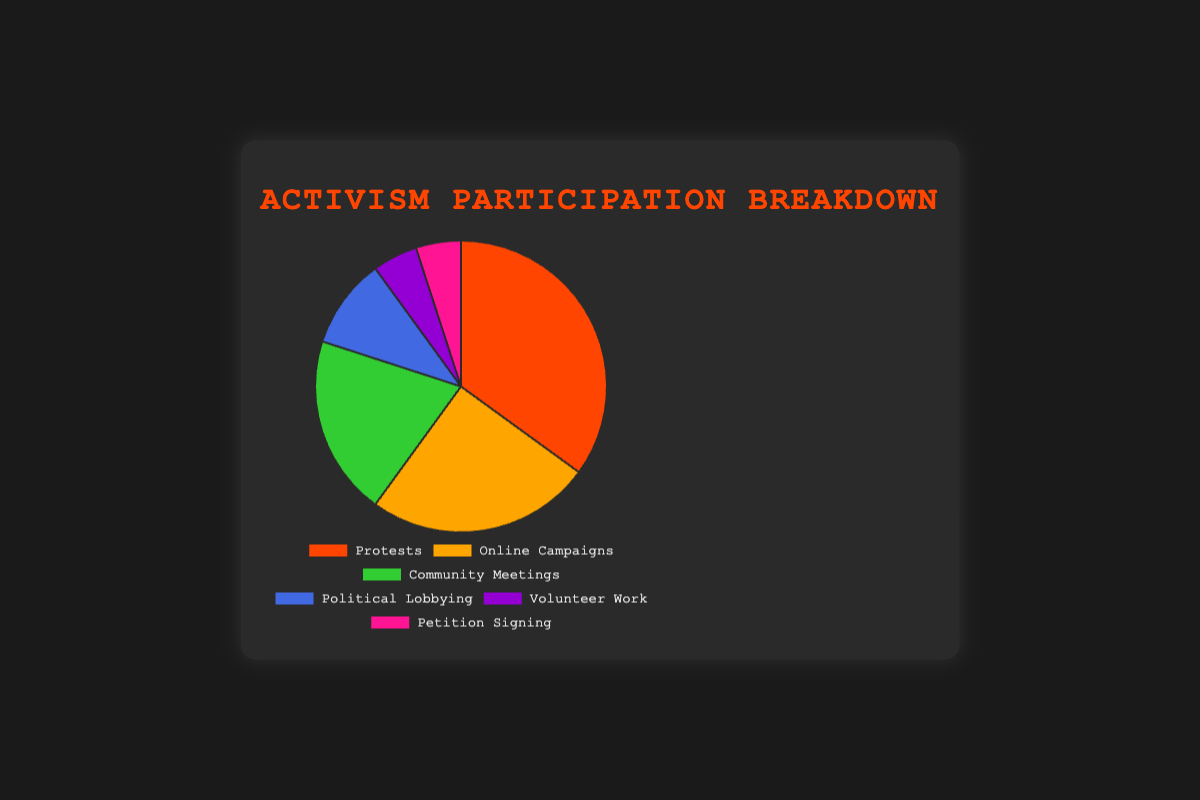Which form of activism has the highest participation percentage? The pie chart shows segments labeled with various forms of activism and their corresponding percentages. To find the highest participation, compare all the percentage values provided. Protests have the highest percentage at 35%
Answer: Protests How much higher is the percentage of Protests compared to Online Campaigns? Find the percentage for both Protests (35%) and Online Campaigns (25%) from the pie chart. Subtract the percentage of Online Campaigns from Protests: 35% - 25% = 10%
Answer: 10% Is the participation in Volunteer Work and Petition Signing equal to the participation in Community Meetings? According to the pie chart, Volunteer Work is 5% and Petition Signing is 5%. Adding these gives 5% + 5% = 10%. The participation for Community Meetings is 20%. Hence, they are not equal
Answer: No Which forms of activism have the least participation? Observe the segments of the pie chart with small percentages. Both Volunteer Work and Petition Signing have the smallest segments, corresponding to 5% each
Answer: Volunteer Work and Petition Signing What is the total percentage of participation for forms of activism other than Protests and Online Campaigns? The pie chart shows Protests (35%) and Online Campaigns (25%). Calculate the total percentage for all forms (100%) and subtract the percentages for Protests and Online Campaigns: 100% - 35% - 25% = 40%
Answer: 40% What is the combined percentage of Protests and Community Meetings? Find the percentages for Protests (35%) and Community Meetings (20%) from the pie chart. Add these percentages together: 35% + 20% = 55%
Answer: 55% Are Community Meetings more popular than Political Lobbying? From the pie chart, the percentage for Community Meetings is 20%, while for Political Lobbying it is 10%. Since 20% is greater than 10%, Community Meetings are indeed more popular
Answer: Yes How many times more participation does Online Campaigns have compared to Volunteer Work? Find the percentage for Online Campaigns (25%) and Volunteer Work (5%). Divide the percentage of Online Campaigns by that of Volunteer Work: 25% / 5% = 5 times
Answer: 5 times What color represents Political Lobbying in the pie chart? The pie chart segments are distinguished by colors. The segment for Political Lobbying is represented in blue, as described in the data code provided
Answer: Blue 